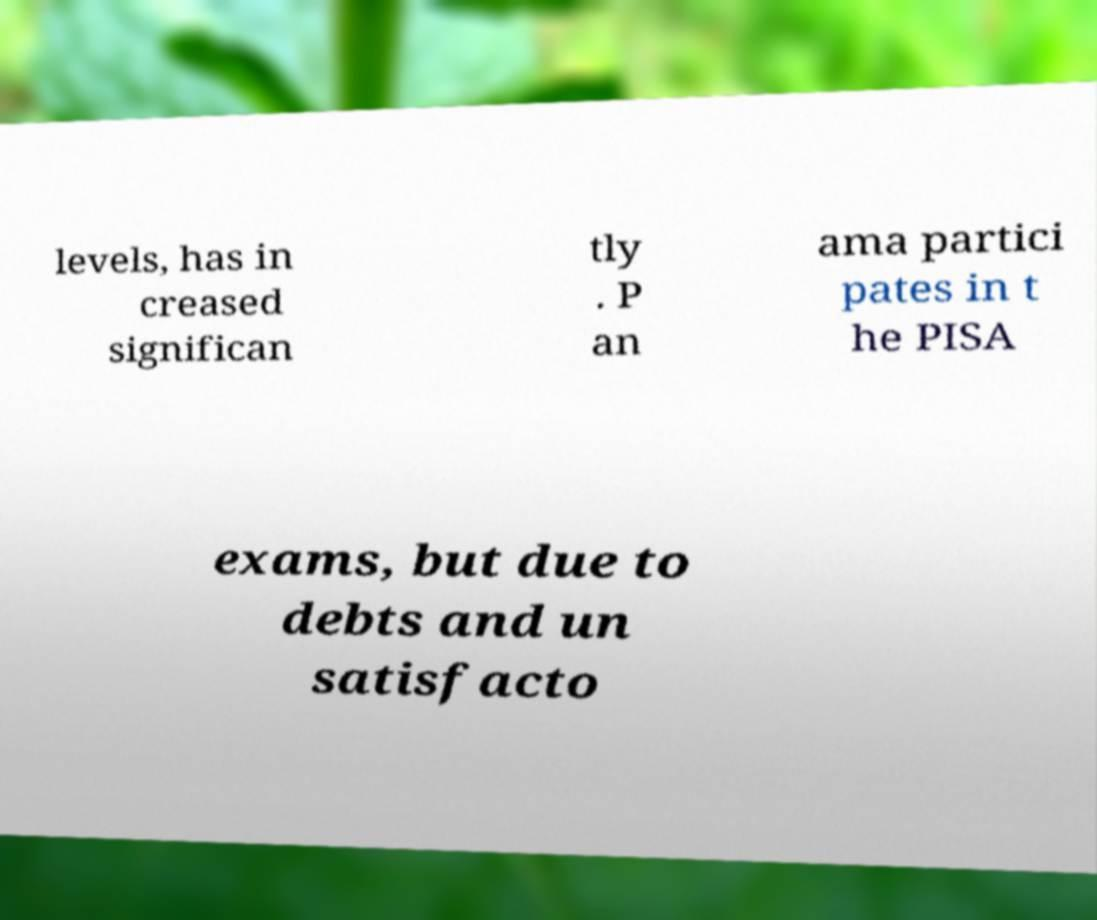Could you extract and type out the text from this image? levels, has in creased significan tly . P an ama partici pates in t he PISA exams, but due to debts and un satisfacto 